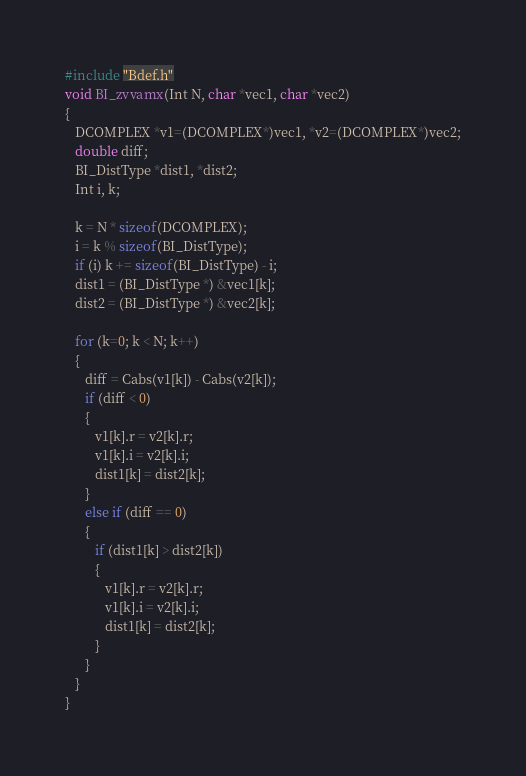<code> <loc_0><loc_0><loc_500><loc_500><_C_>#include "Bdef.h"
void BI_zvvamx(Int N, char *vec1, char *vec2)
{
   DCOMPLEX *v1=(DCOMPLEX*)vec1, *v2=(DCOMPLEX*)vec2;
   double diff;
   BI_DistType *dist1, *dist2;
   Int i, k;

   k = N * sizeof(DCOMPLEX);
   i = k % sizeof(BI_DistType);
   if (i) k += sizeof(BI_DistType) - i;
   dist1 = (BI_DistType *) &vec1[k];
   dist2 = (BI_DistType *) &vec2[k];

   for (k=0; k < N; k++)
   {
      diff = Cabs(v1[k]) - Cabs(v2[k]);
      if (diff < 0)
      {
         v1[k].r = v2[k].r;
         v1[k].i = v2[k].i;
         dist1[k] = dist2[k];
      }
      else if (diff == 0)
      {
         if (dist1[k] > dist2[k])
         {
            v1[k].r = v2[k].r;
            v1[k].i = v2[k].i;
            dist1[k] = dist2[k];
         }
      }
   }
}
</code> 